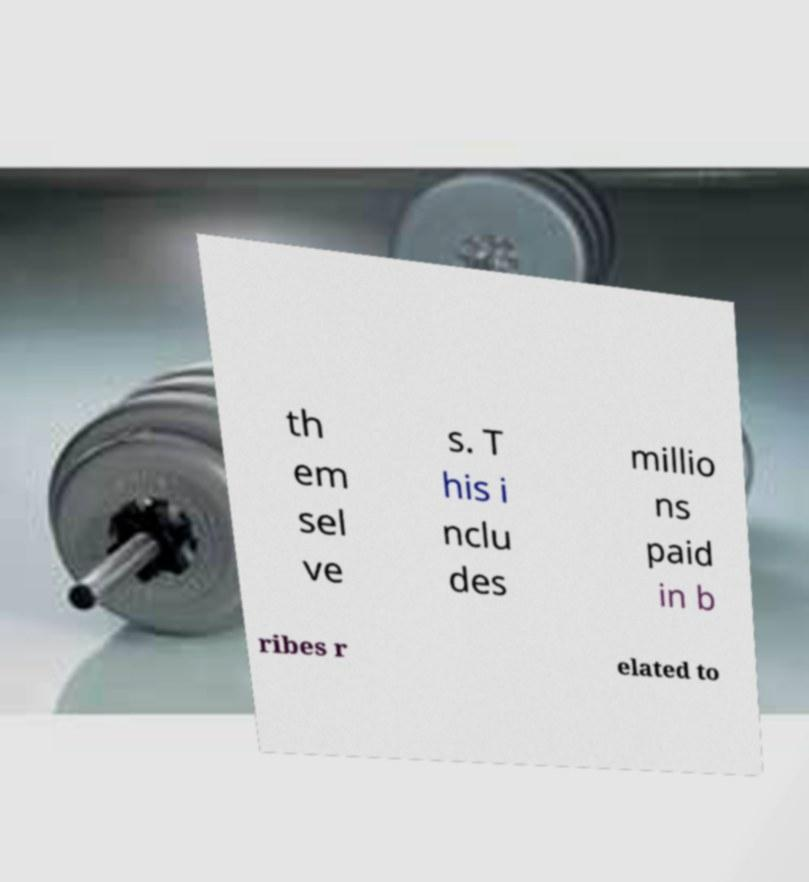I need the written content from this picture converted into text. Can you do that? th em sel ve s. T his i nclu des millio ns paid in b ribes r elated to 